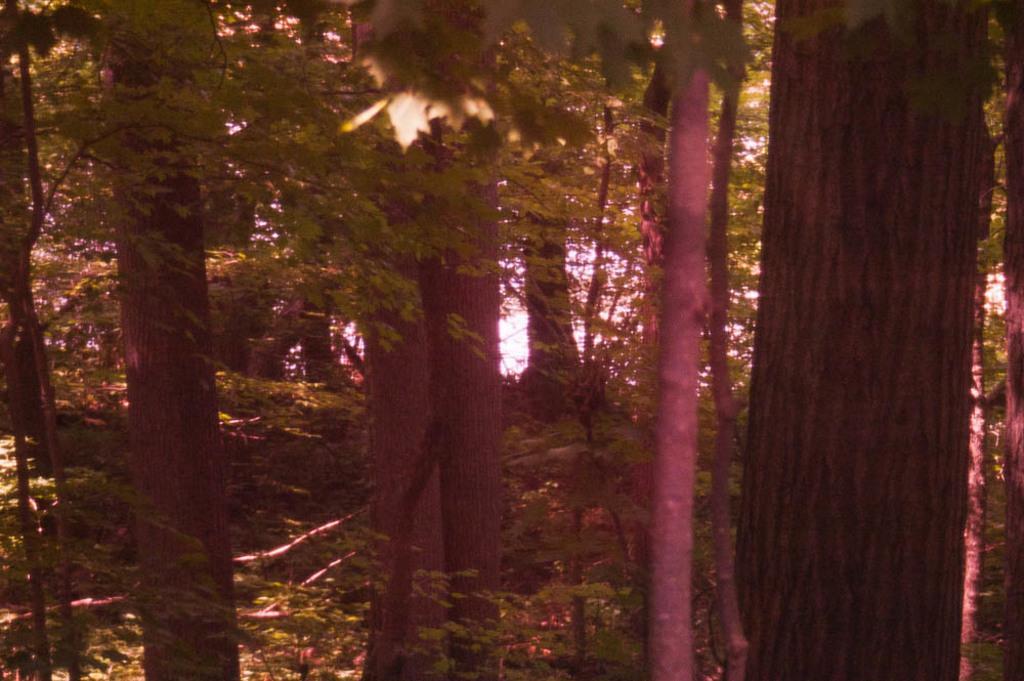Can you describe this image briefly? In the picture we can see a full of trees, and tree branches and near to it we can see some plants and grass. 